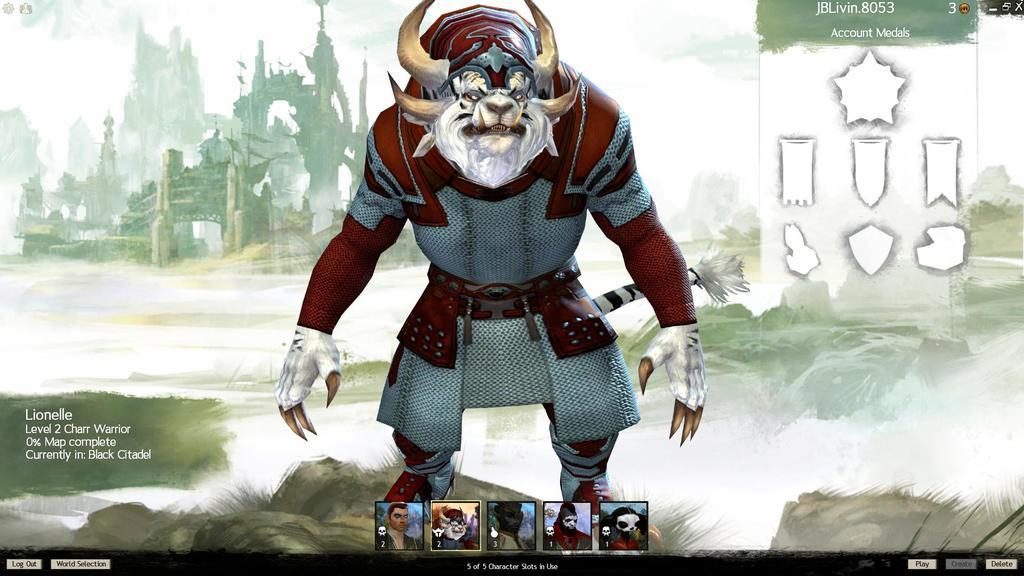What type of image is being described? The image is an animated image. What kind of content is present in the image? There are cartoon pictures in the image. What type of structure can be seen in the image? There is a building in the image. What part of the natural environment is visible in the image? The sky is visible in the image. What else can be found in the image besides the building and cartoon pictures? There are pictures and text in the image. How many clouds are visible in the image? There is no mention of clouds in the image; only the sky is visible. What type of book is the character reading in the image? There is no character reading a book in the image; it is an animated image with cartoon pictures and text. 